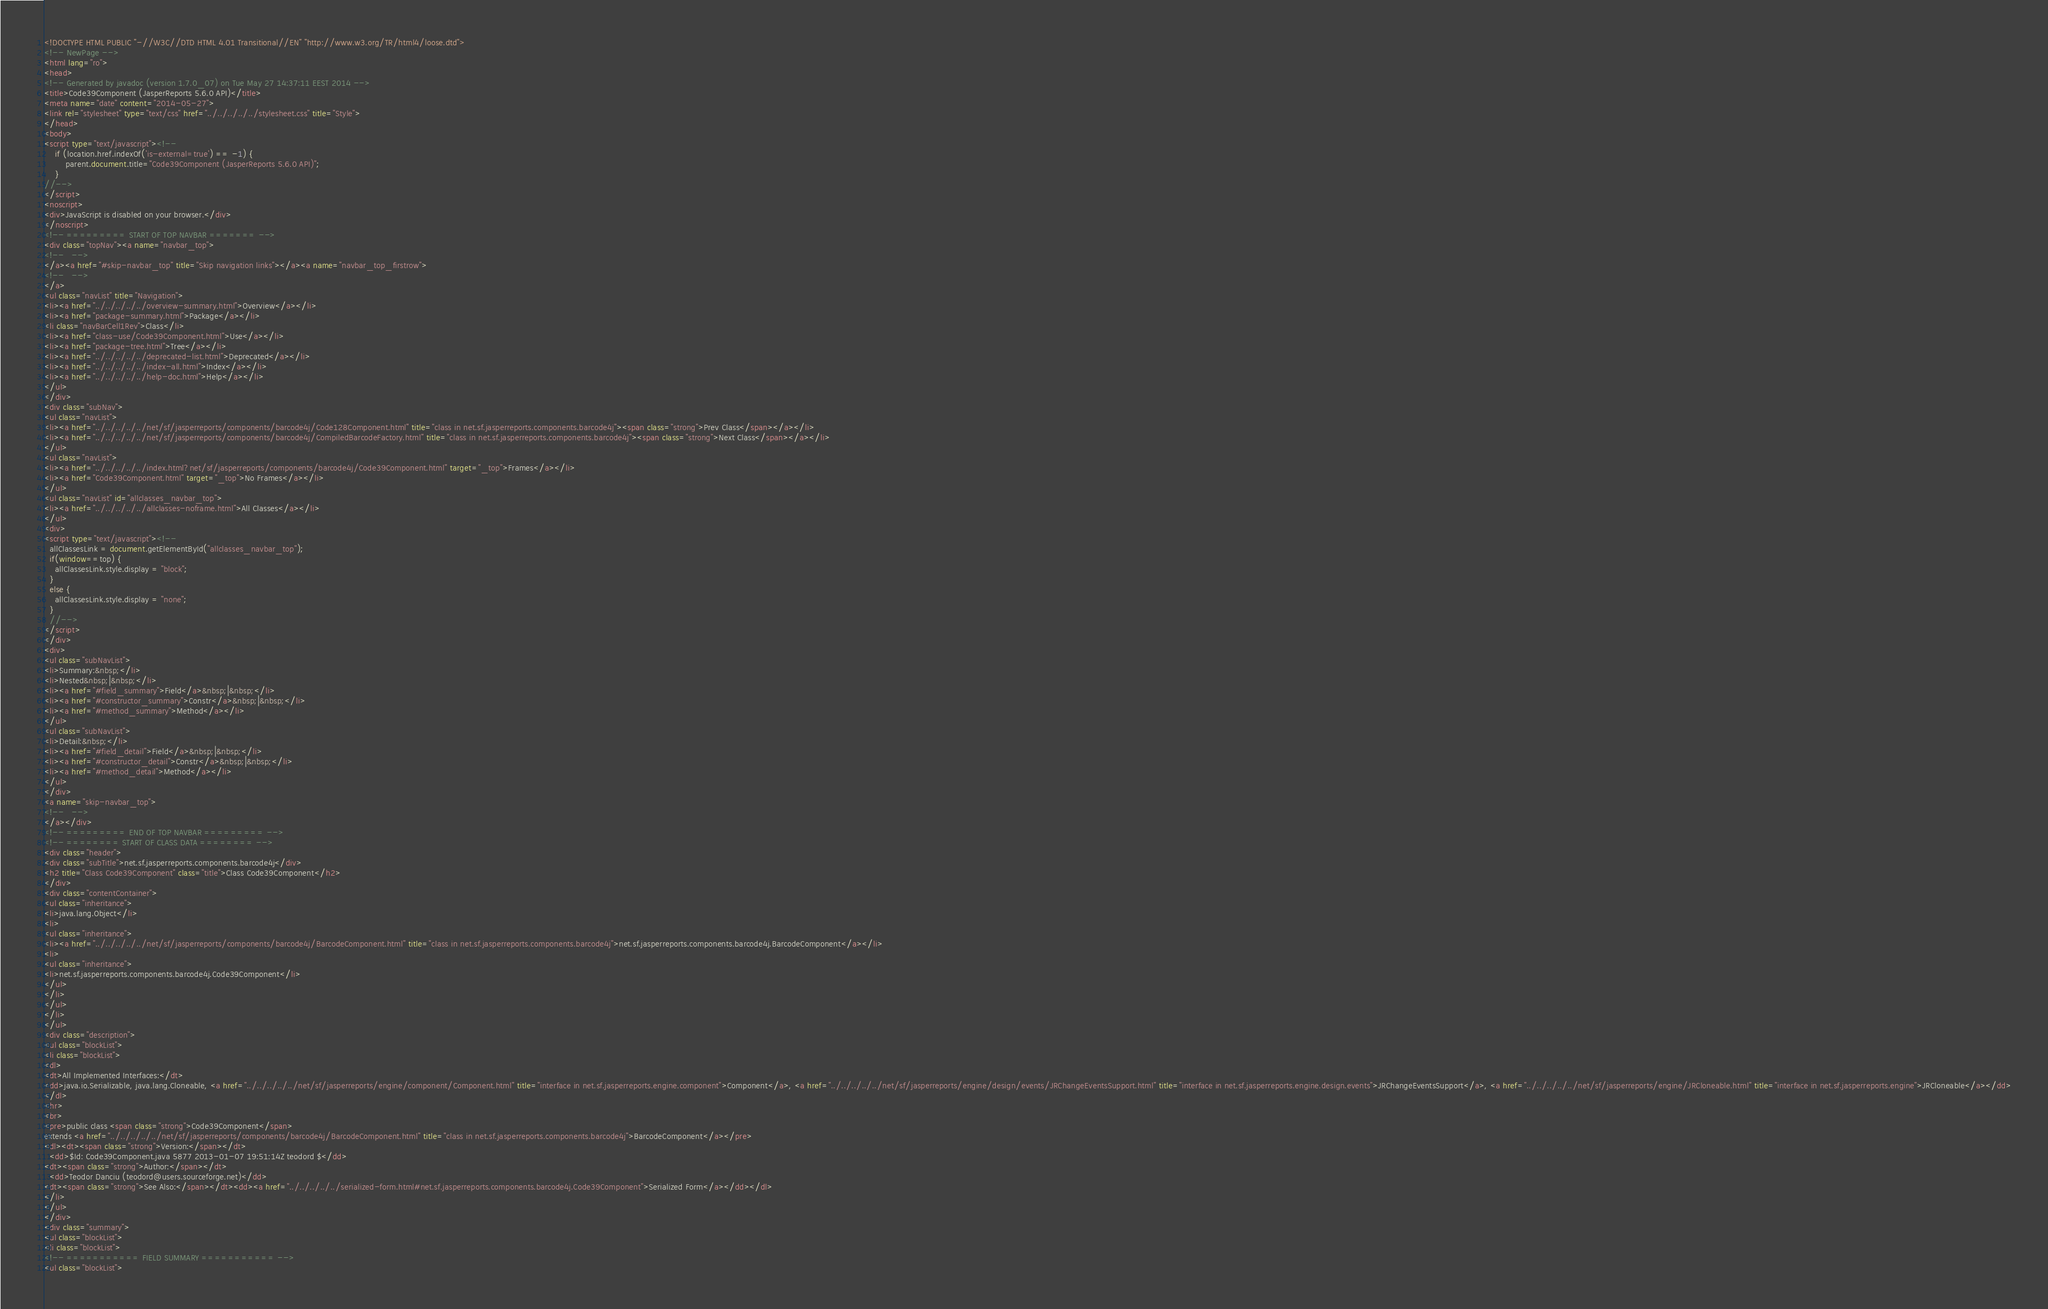Convert code to text. <code><loc_0><loc_0><loc_500><loc_500><_HTML_><!DOCTYPE HTML PUBLIC "-//W3C//DTD HTML 4.01 Transitional//EN" "http://www.w3.org/TR/html4/loose.dtd">
<!-- NewPage -->
<html lang="ro">
<head>
<!-- Generated by javadoc (version 1.7.0_07) on Tue May 27 14:37:11 EEST 2014 -->
<title>Code39Component (JasperReports 5.6.0 API)</title>
<meta name="date" content="2014-05-27">
<link rel="stylesheet" type="text/css" href="../../../../../stylesheet.css" title="Style">
</head>
<body>
<script type="text/javascript"><!--
    if (location.href.indexOf('is-external=true') == -1) {
        parent.document.title="Code39Component (JasperReports 5.6.0 API)";
    }
//-->
</script>
<noscript>
<div>JavaScript is disabled on your browser.</div>
</noscript>
<!-- ========= START OF TOP NAVBAR ======= -->
<div class="topNav"><a name="navbar_top">
<!--   -->
</a><a href="#skip-navbar_top" title="Skip navigation links"></a><a name="navbar_top_firstrow">
<!--   -->
</a>
<ul class="navList" title="Navigation">
<li><a href="../../../../../overview-summary.html">Overview</a></li>
<li><a href="package-summary.html">Package</a></li>
<li class="navBarCell1Rev">Class</li>
<li><a href="class-use/Code39Component.html">Use</a></li>
<li><a href="package-tree.html">Tree</a></li>
<li><a href="../../../../../deprecated-list.html">Deprecated</a></li>
<li><a href="../../../../../index-all.html">Index</a></li>
<li><a href="../../../../../help-doc.html">Help</a></li>
</ul>
</div>
<div class="subNav">
<ul class="navList">
<li><a href="../../../../../net/sf/jasperreports/components/barcode4j/Code128Component.html" title="class in net.sf.jasperreports.components.barcode4j"><span class="strong">Prev Class</span></a></li>
<li><a href="../../../../../net/sf/jasperreports/components/barcode4j/CompiledBarcodeFactory.html" title="class in net.sf.jasperreports.components.barcode4j"><span class="strong">Next Class</span></a></li>
</ul>
<ul class="navList">
<li><a href="../../../../../index.html?net/sf/jasperreports/components/barcode4j/Code39Component.html" target="_top">Frames</a></li>
<li><a href="Code39Component.html" target="_top">No Frames</a></li>
</ul>
<ul class="navList" id="allclasses_navbar_top">
<li><a href="../../../../../allclasses-noframe.html">All Classes</a></li>
</ul>
<div>
<script type="text/javascript"><!--
  allClassesLink = document.getElementById("allclasses_navbar_top");
  if(window==top) {
    allClassesLink.style.display = "block";
  }
  else {
    allClassesLink.style.display = "none";
  }
  //-->
</script>
</div>
<div>
<ul class="subNavList">
<li>Summary:&nbsp;</li>
<li>Nested&nbsp;|&nbsp;</li>
<li><a href="#field_summary">Field</a>&nbsp;|&nbsp;</li>
<li><a href="#constructor_summary">Constr</a>&nbsp;|&nbsp;</li>
<li><a href="#method_summary">Method</a></li>
</ul>
<ul class="subNavList">
<li>Detail:&nbsp;</li>
<li><a href="#field_detail">Field</a>&nbsp;|&nbsp;</li>
<li><a href="#constructor_detail">Constr</a>&nbsp;|&nbsp;</li>
<li><a href="#method_detail">Method</a></li>
</ul>
</div>
<a name="skip-navbar_top">
<!--   -->
</a></div>
<!-- ========= END OF TOP NAVBAR ========= -->
<!-- ======== START OF CLASS DATA ======== -->
<div class="header">
<div class="subTitle">net.sf.jasperreports.components.barcode4j</div>
<h2 title="Class Code39Component" class="title">Class Code39Component</h2>
</div>
<div class="contentContainer">
<ul class="inheritance">
<li>java.lang.Object</li>
<li>
<ul class="inheritance">
<li><a href="../../../../../net/sf/jasperreports/components/barcode4j/BarcodeComponent.html" title="class in net.sf.jasperreports.components.barcode4j">net.sf.jasperreports.components.barcode4j.BarcodeComponent</a></li>
<li>
<ul class="inheritance">
<li>net.sf.jasperreports.components.barcode4j.Code39Component</li>
</ul>
</li>
</ul>
</li>
</ul>
<div class="description">
<ul class="blockList">
<li class="blockList">
<dl>
<dt>All Implemented Interfaces:</dt>
<dd>java.io.Serializable, java.lang.Cloneable, <a href="../../../../../net/sf/jasperreports/engine/component/Component.html" title="interface in net.sf.jasperreports.engine.component">Component</a>, <a href="../../../../../net/sf/jasperreports/engine/design/events/JRChangeEventsSupport.html" title="interface in net.sf.jasperreports.engine.design.events">JRChangeEventsSupport</a>, <a href="../../../../../net/sf/jasperreports/engine/JRCloneable.html" title="interface in net.sf.jasperreports.engine">JRCloneable</a></dd>
</dl>
<hr>
<br>
<pre>public class <span class="strong">Code39Component</span>
extends <a href="../../../../../net/sf/jasperreports/components/barcode4j/BarcodeComponent.html" title="class in net.sf.jasperreports.components.barcode4j">BarcodeComponent</a></pre>
<dl><dt><span class="strong">Version:</span></dt>
  <dd>$Id: Code39Component.java 5877 2013-01-07 19:51:14Z teodord $</dd>
<dt><span class="strong">Author:</span></dt>
  <dd>Teodor Danciu (teodord@users.sourceforge.net)</dd>
<dt><span class="strong">See Also:</span></dt><dd><a href="../../../../../serialized-form.html#net.sf.jasperreports.components.barcode4j.Code39Component">Serialized Form</a></dd></dl>
</li>
</ul>
</div>
<div class="summary">
<ul class="blockList">
<li class="blockList">
<!-- =========== FIELD SUMMARY =========== -->
<ul class="blockList"></code> 